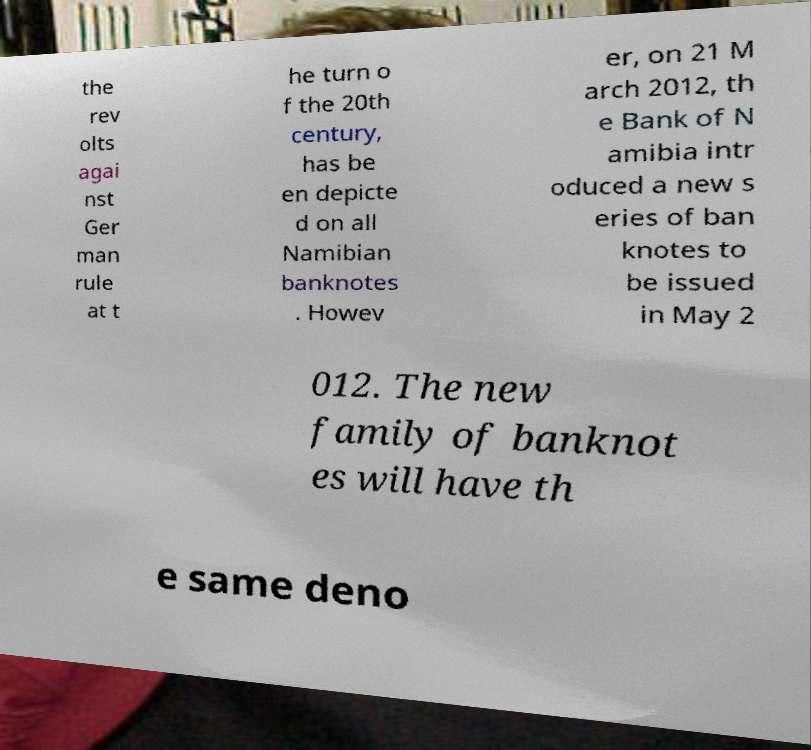Please read and relay the text visible in this image. What does it say? the rev olts agai nst Ger man rule at t he turn o f the 20th century, has be en depicte d on all Namibian banknotes . Howev er, on 21 M arch 2012, th e Bank of N amibia intr oduced a new s eries of ban knotes to be issued in May 2 012. The new family of banknot es will have th e same deno 